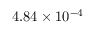<formula> <loc_0><loc_0><loc_500><loc_500>4 . 8 4 \times 1 0 ^ { - 4 }</formula> 